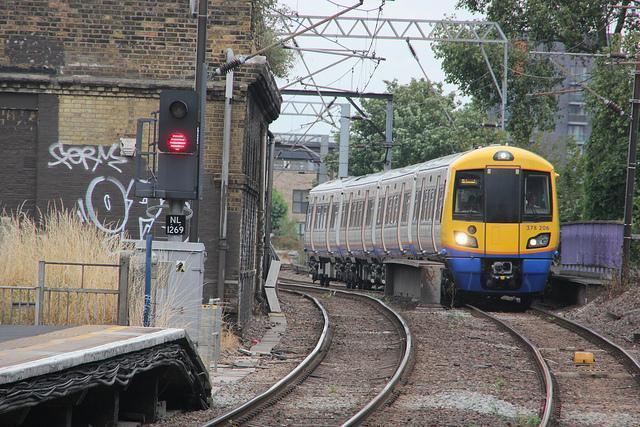How many traffic lights are in the picture?
Give a very brief answer. 1. 